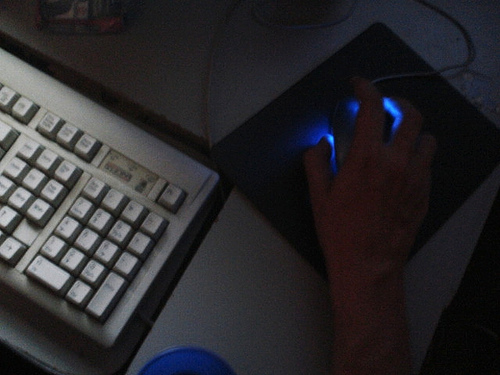<image>Does it have any red buttons? No, it does not have any red buttons. Does it have any red buttons? No, it does not have any red buttons. 